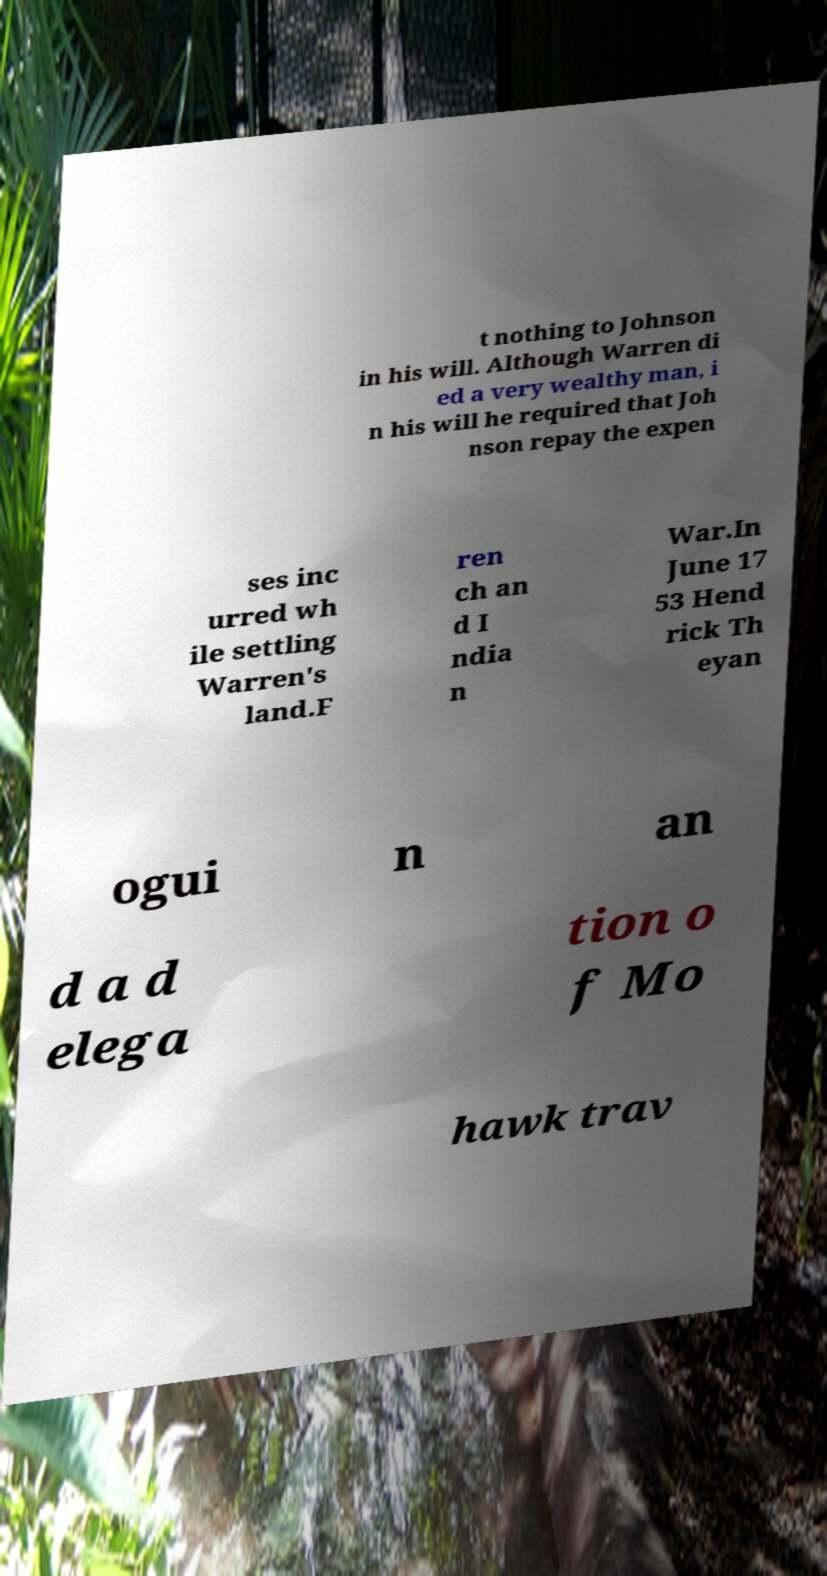Please read and relay the text visible in this image. What does it say? t nothing to Johnson in his will. Although Warren di ed a very wealthy man, i n his will he required that Joh nson repay the expen ses inc urred wh ile settling Warren's land.F ren ch an d I ndia n War.In June 17 53 Hend rick Th eyan ogui n an d a d elega tion o f Mo hawk trav 